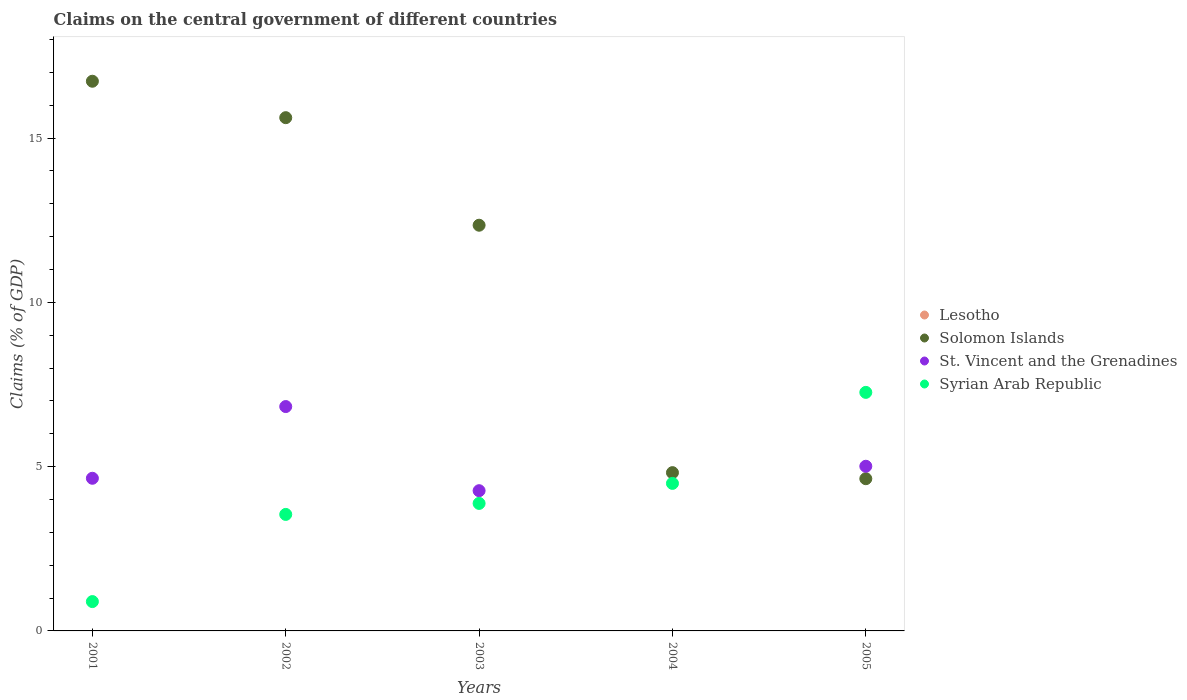Is the number of dotlines equal to the number of legend labels?
Your response must be concise. No. What is the percentage of GDP claimed on the central government in Syrian Arab Republic in 2005?
Your answer should be very brief. 7.26. Across all years, what is the maximum percentage of GDP claimed on the central government in St. Vincent and the Grenadines?
Offer a very short reply. 6.83. Across all years, what is the minimum percentage of GDP claimed on the central government in Syrian Arab Republic?
Keep it short and to the point. 0.89. What is the difference between the percentage of GDP claimed on the central government in St. Vincent and the Grenadines in 2003 and that in 2005?
Provide a short and direct response. -0.74. What is the difference between the percentage of GDP claimed on the central government in St. Vincent and the Grenadines in 2004 and the percentage of GDP claimed on the central government in Syrian Arab Republic in 2002?
Your response must be concise. -3.55. What is the average percentage of GDP claimed on the central government in Solomon Islands per year?
Your response must be concise. 10.83. In the year 2003, what is the difference between the percentage of GDP claimed on the central government in Syrian Arab Republic and percentage of GDP claimed on the central government in Solomon Islands?
Your answer should be very brief. -8.47. What is the ratio of the percentage of GDP claimed on the central government in Solomon Islands in 2004 to that in 2005?
Ensure brevity in your answer.  1.04. Is the difference between the percentage of GDP claimed on the central government in Syrian Arab Republic in 2003 and 2005 greater than the difference between the percentage of GDP claimed on the central government in Solomon Islands in 2003 and 2005?
Your answer should be very brief. No. What is the difference between the highest and the second highest percentage of GDP claimed on the central government in Solomon Islands?
Ensure brevity in your answer.  1.11. What is the difference between the highest and the lowest percentage of GDP claimed on the central government in Syrian Arab Republic?
Your answer should be very brief. 6.37. Is it the case that in every year, the sum of the percentage of GDP claimed on the central government in Solomon Islands and percentage of GDP claimed on the central government in Lesotho  is greater than the sum of percentage of GDP claimed on the central government in Syrian Arab Republic and percentage of GDP claimed on the central government in St. Vincent and the Grenadines?
Provide a succinct answer. No. Does the percentage of GDP claimed on the central government in St. Vincent and the Grenadines monotonically increase over the years?
Provide a succinct answer. No. Is the percentage of GDP claimed on the central government in Lesotho strictly greater than the percentage of GDP claimed on the central government in St. Vincent and the Grenadines over the years?
Your answer should be compact. No. How many dotlines are there?
Your answer should be compact. 3. How many years are there in the graph?
Provide a succinct answer. 5. Are the values on the major ticks of Y-axis written in scientific E-notation?
Provide a short and direct response. No. Does the graph contain any zero values?
Provide a short and direct response. Yes. Does the graph contain grids?
Your response must be concise. No. Where does the legend appear in the graph?
Offer a terse response. Center right. How many legend labels are there?
Provide a succinct answer. 4. What is the title of the graph?
Your response must be concise. Claims on the central government of different countries. Does "Iraq" appear as one of the legend labels in the graph?
Your answer should be compact. No. What is the label or title of the Y-axis?
Give a very brief answer. Claims (% of GDP). What is the Claims (% of GDP) of Lesotho in 2001?
Give a very brief answer. 0. What is the Claims (% of GDP) in Solomon Islands in 2001?
Your answer should be compact. 16.73. What is the Claims (% of GDP) of St. Vincent and the Grenadines in 2001?
Ensure brevity in your answer.  4.65. What is the Claims (% of GDP) of Syrian Arab Republic in 2001?
Ensure brevity in your answer.  0.89. What is the Claims (% of GDP) in Solomon Islands in 2002?
Give a very brief answer. 15.62. What is the Claims (% of GDP) of St. Vincent and the Grenadines in 2002?
Keep it short and to the point. 6.83. What is the Claims (% of GDP) of Syrian Arab Republic in 2002?
Offer a terse response. 3.55. What is the Claims (% of GDP) in Lesotho in 2003?
Make the answer very short. 0. What is the Claims (% of GDP) of Solomon Islands in 2003?
Offer a terse response. 12.35. What is the Claims (% of GDP) in St. Vincent and the Grenadines in 2003?
Offer a very short reply. 4.27. What is the Claims (% of GDP) of Syrian Arab Republic in 2003?
Offer a terse response. 3.88. What is the Claims (% of GDP) of Lesotho in 2004?
Your answer should be very brief. 0. What is the Claims (% of GDP) of Solomon Islands in 2004?
Offer a very short reply. 4.82. What is the Claims (% of GDP) of Syrian Arab Republic in 2004?
Offer a very short reply. 4.49. What is the Claims (% of GDP) of Lesotho in 2005?
Keep it short and to the point. 0. What is the Claims (% of GDP) in Solomon Islands in 2005?
Make the answer very short. 4.63. What is the Claims (% of GDP) of St. Vincent and the Grenadines in 2005?
Your answer should be very brief. 5.01. What is the Claims (% of GDP) in Syrian Arab Republic in 2005?
Give a very brief answer. 7.26. Across all years, what is the maximum Claims (% of GDP) in Solomon Islands?
Your answer should be very brief. 16.73. Across all years, what is the maximum Claims (% of GDP) of St. Vincent and the Grenadines?
Offer a terse response. 6.83. Across all years, what is the maximum Claims (% of GDP) of Syrian Arab Republic?
Provide a succinct answer. 7.26. Across all years, what is the minimum Claims (% of GDP) of Solomon Islands?
Provide a succinct answer. 4.63. Across all years, what is the minimum Claims (% of GDP) in St. Vincent and the Grenadines?
Make the answer very short. 0. Across all years, what is the minimum Claims (% of GDP) of Syrian Arab Republic?
Provide a short and direct response. 0.89. What is the total Claims (% of GDP) of Lesotho in the graph?
Ensure brevity in your answer.  0. What is the total Claims (% of GDP) of Solomon Islands in the graph?
Your response must be concise. 54.15. What is the total Claims (% of GDP) in St. Vincent and the Grenadines in the graph?
Your response must be concise. 20.76. What is the total Claims (% of GDP) of Syrian Arab Republic in the graph?
Provide a short and direct response. 20.07. What is the difference between the Claims (% of GDP) of Solomon Islands in 2001 and that in 2002?
Provide a short and direct response. 1.11. What is the difference between the Claims (% of GDP) of St. Vincent and the Grenadines in 2001 and that in 2002?
Offer a very short reply. -2.18. What is the difference between the Claims (% of GDP) in Syrian Arab Republic in 2001 and that in 2002?
Provide a short and direct response. -2.65. What is the difference between the Claims (% of GDP) in Solomon Islands in 2001 and that in 2003?
Your answer should be compact. 4.38. What is the difference between the Claims (% of GDP) in St. Vincent and the Grenadines in 2001 and that in 2003?
Ensure brevity in your answer.  0.38. What is the difference between the Claims (% of GDP) of Syrian Arab Republic in 2001 and that in 2003?
Ensure brevity in your answer.  -2.99. What is the difference between the Claims (% of GDP) of Solomon Islands in 2001 and that in 2004?
Provide a succinct answer. 11.91. What is the difference between the Claims (% of GDP) of Syrian Arab Republic in 2001 and that in 2004?
Ensure brevity in your answer.  -3.6. What is the difference between the Claims (% of GDP) in Solomon Islands in 2001 and that in 2005?
Make the answer very short. 12.1. What is the difference between the Claims (% of GDP) in St. Vincent and the Grenadines in 2001 and that in 2005?
Make the answer very short. -0.37. What is the difference between the Claims (% of GDP) in Syrian Arab Republic in 2001 and that in 2005?
Offer a terse response. -6.37. What is the difference between the Claims (% of GDP) of Solomon Islands in 2002 and that in 2003?
Your answer should be compact. 3.27. What is the difference between the Claims (% of GDP) in St. Vincent and the Grenadines in 2002 and that in 2003?
Give a very brief answer. 2.56. What is the difference between the Claims (% of GDP) in Syrian Arab Republic in 2002 and that in 2003?
Your answer should be very brief. -0.33. What is the difference between the Claims (% of GDP) of Solomon Islands in 2002 and that in 2004?
Ensure brevity in your answer.  10.8. What is the difference between the Claims (% of GDP) of Syrian Arab Republic in 2002 and that in 2004?
Keep it short and to the point. -0.94. What is the difference between the Claims (% of GDP) of Solomon Islands in 2002 and that in 2005?
Your answer should be very brief. 10.99. What is the difference between the Claims (% of GDP) in St. Vincent and the Grenadines in 2002 and that in 2005?
Your response must be concise. 1.82. What is the difference between the Claims (% of GDP) of Syrian Arab Republic in 2002 and that in 2005?
Offer a terse response. -3.71. What is the difference between the Claims (% of GDP) in Solomon Islands in 2003 and that in 2004?
Keep it short and to the point. 7.53. What is the difference between the Claims (% of GDP) of Syrian Arab Republic in 2003 and that in 2004?
Provide a short and direct response. -0.61. What is the difference between the Claims (% of GDP) in Solomon Islands in 2003 and that in 2005?
Ensure brevity in your answer.  7.72. What is the difference between the Claims (% of GDP) in St. Vincent and the Grenadines in 2003 and that in 2005?
Provide a succinct answer. -0.74. What is the difference between the Claims (% of GDP) in Syrian Arab Republic in 2003 and that in 2005?
Your response must be concise. -3.38. What is the difference between the Claims (% of GDP) of Solomon Islands in 2004 and that in 2005?
Your response must be concise. 0.18. What is the difference between the Claims (% of GDP) in Syrian Arab Republic in 2004 and that in 2005?
Your response must be concise. -2.77. What is the difference between the Claims (% of GDP) in Solomon Islands in 2001 and the Claims (% of GDP) in St. Vincent and the Grenadines in 2002?
Your answer should be compact. 9.9. What is the difference between the Claims (% of GDP) of Solomon Islands in 2001 and the Claims (% of GDP) of Syrian Arab Republic in 2002?
Your response must be concise. 13.18. What is the difference between the Claims (% of GDP) of Solomon Islands in 2001 and the Claims (% of GDP) of St. Vincent and the Grenadines in 2003?
Provide a short and direct response. 12.46. What is the difference between the Claims (% of GDP) of Solomon Islands in 2001 and the Claims (% of GDP) of Syrian Arab Republic in 2003?
Keep it short and to the point. 12.85. What is the difference between the Claims (% of GDP) in St. Vincent and the Grenadines in 2001 and the Claims (% of GDP) in Syrian Arab Republic in 2003?
Your answer should be very brief. 0.77. What is the difference between the Claims (% of GDP) of Solomon Islands in 2001 and the Claims (% of GDP) of Syrian Arab Republic in 2004?
Your answer should be very brief. 12.24. What is the difference between the Claims (% of GDP) of St. Vincent and the Grenadines in 2001 and the Claims (% of GDP) of Syrian Arab Republic in 2004?
Your answer should be very brief. 0.16. What is the difference between the Claims (% of GDP) in Solomon Islands in 2001 and the Claims (% of GDP) in St. Vincent and the Grenadines in 2005?
Offer a terse response. 11.72. What is the difference between the Claims (% of GDP) in Solomon Islands in 2001 and the Claims (% of GDP) in Syrian Arab Republic in 2005?
Offer a very short reply. 9.47. What is the difference between the Claims (% of GDP) of St. Vincent and the Grenadines in 2001 and the Claims (% of GDP) of Syrian Arab Republic in 2005?
Provide a short and direct response. -2.61. What is the difference between the Claims (% of GDP) of Solomon Islands in 2002 and the Claims (% of GDP) of St. Vincent and the Grenadines in 2003?
Offer a very short reply. 11.35. What is the difference between the Claims (% of GDP) in Solomon Islands in 2002 and the Claims (% of GDP) in Syrian Arab Republic in 2003?
Offer a terse response. 11.74. What is the difference between the Claims (% of GDP) in St. Vincent and the Grenadines in 2002 and the Claims (% of GDP) in Syrian Arab Republic in 2003?
Keep it short and to the point. 2.95. What is the difference between the Claims (% of GDP) in Solomon Islands in 2002 and the Claims (% of GDP) in Syrian Arab Republic in 2004?
Your response must be concise. 11.13. What is the difference between the Claims (% of GDP) in St. Vincent and the Grenadines in 2002 and the Claims (% of GDP) in Syrian Arab Republic in 2004?
Keep it short and to the point. 2.34. What is the difference between the Claims (% of GDP) of Solomon Islands in 2002 and the Claims (% of GDP) of St. Vincent and the Grenadines in 2005?
Provide a succinct answer. 10.61. What is the difference between the Claims (% of GDP) in Solomon Islands in 2002 and the Claims (% of GDP) in Syrian Arab Republic in 2005?
Ensure brevity in your answer.  8.36. What is the difference between the Claims (% of GDP) of St. Vincent and the Grenadines in 2002 and the Claims (% of GDP) of Syrian Arab Republic in 2005?
Provide a short and direct response. -0.43. What is the difference between the Claims (% of GDP) of Solomon Islands in 2003 and the Claims (% of GDP) of Syrian Arab Republic in 2004?
Provide a short and direct response. 7.86. What is the difference between the Claims (% of GDP) of St. Vincent and the Grenadines in 2003 and the Claims (% of GDP) of Syrian Arab Republic in 2004?
Provide a short and direct response. -0.22. What is the difference between the Claims (% of GDP) of Solomon Islands in 2003 and the Claims (% of GDP) of St. Vincent and the Grenadines in 2005?
Offer a very short reply. 7.34. What is the difference between the Claims (% of GDP) in Solomon Islands in 2003 and the Claims (% of GDP) in Syrian Arab Republic in 2005?
Give a very brief answer. 5.09. What is the difference between the Claims (% of GDP) in St. Vincent and the Grenadines in 2003 and the Claims (% of GDP) in Syrian Arab Republic in 2005?
Your answer should be very brief. -2.99. What is the difference between the Claims (% of GDP) in Solomon Islands in 2004 and the Claims (% of GDP) in St. Vincent and the Grenadines in 2005?
Make the answer very short. -0.19. What is the difference between the Claims (% of GDP) in Solomon Islands in 2004 and the Claims (% of GDP) in Syrian Arab Republic in 2005?
Your answer should be very brief. -2.44. What is the average Claims (% of GDP) in Lesotho per year?
Your response must be concise. 0. What is the average Claims (% of GDP) of Solomon Islands per year?
Ensure brevity in your answer.  10.83. What is the average Claims (% of GDP) in St. Vincent and the Grenadines per year?
Give a very brief answer. 4.15. What is the average Claims (% of GDP) of Syrian Arab Republic per year?
Provide a succinct answer. 4.01. In the year 2001, what is the difference between the Claims (% of GDP) in Solomon Islands and Claims (% of GDP) in St. Vincent and the Grenadines?
Your answer should be compact. 12.08. In the year 2001, what is the difference between the Claims (% of GDP) of Solomon Islands and Claims (% of GDP) of Syrian Arab Republic?
Offer a terse response. 15.84. In the year 2001, what is the difference between the Claims (% of GDP) of St. Vincent and the Grenadines and Claims (% of GDP) of Syrian Arab Republic?
Your answer should be compact. 3.75. In the year 2002, what is the difference between the Claims (% of GDP) in Solomon Islands and Claims (% of GDP) in St. Vincent and the Grenadines?
Offer a terse response. 8.79. In the year 2002, what is the difference between the Claims (% of GDP) of Solomon Islands and Claims (% of GDP) of Syrian Arab Republic?
Your response must be concise. 12.08. In the year 2002, what is the difference between the Claims (% of GDP) in St. Vincent and the Grenadines and Claims (% of GDP) in Syrian Arab Republic?
Your answer should be very brief. 3.28. In the year 2003, what is the difference between the Claims (% of GDP) in Solomon Islands and Claims (% of GDP) in St. Vincent and the Grenadines?
Make the answer very short. 8.08. In the year 2003, what is the difference between the Claims (% of GDP) in Solomon Islands and Claims (% of GDP) in Syrian Arab Republic?
Make the answer very short. 8.47. In the year 2003, what is the difference between the Claims (% of GDP) in St. Vincent and the Grenadines and Claims (% of GDP) in Syrian Arab Republic?
Your answer should be compact. 0.39. In the year 2004, what is the difference between the Claims (% of GDP) of Solomon Islands and Claims (% of GDP) of Syrian Arab Republic?
Provide a short and direct response. 0.33. In the year 2005, what is the difference between the Claims (% of GDP) of Solomon Islands and Claims (% of GDP) of St. Vincent and the Grenadines?
Ensure brevity in your answer.  -0.38. In the year 2005, what is the difference between the Claims (% of GDP) in Solomon Islands and Claims (% of GDP) in Syrian Arab Republic?
Offer a terse response. -2.63. In the year 2005, what is the difference between the Claims (% of GDP) of St. Vincent and the Grenadines and Claims (% of GDP) of Syrian Arab Republic?
Your answer should be very brief. -2.25. What is the ratio of the Claims (% of GDP) of Solomon Islands in 2001 to that in 2002?
Give a very brief answer. 1.07. What is the ratio of the Claims (% of GDP) of St. Vincent and the Grenadines in 2001 to that in 2002?
Your response must be concise. 0.68. What is the ratio of the Claims (% of GDP) in Syrian Arab Republic in 2001 to that in 2002?
Make the answer very short. 0.25. What is the ratio of the Claims (% of GDP) of Solomon Islands in 2001 to that in 2003?
Provide a short and direct response. 1.35. What is the ratio of the Claims (% of GDP) of St. Vincent and the Grenadines in 2001 to that in 2003?
Your answer should be very brief. 1.09. What is the ratio of the Claims (% of GDP) of Syrian Arab Republic in 2001 to that in 2003?
Give a very brief answer. 0.23. What is the ratio of the Claims (% of GDP) in Solomon Islands in 2001 to that in 2004?
Keep it short and to the point. 3.47. What is the ratio of the Claims (% of GDP) of Syrian Arab Republic in 2001 to that in 2004?
Give a very brief answer. 0.2. What is the ratio of the Claims (% of GDP) of Solomon Islands in 2001 to that in 2005?
Your answer should be compact. 3.61. What is the ratio of the Claims (% of GDP) of St. Vincent and the Grenadines in 2001 to that in 2005?
Provide a succinct answer. 0.93. What is the ratio of the Claims (% of GDP) in Syrian Arab Republic in 2001 to that in 2005?
Keep it short and to the point. 0.12. What is the ratio of the Claims (% of GDP) of Solomon Islands in 2002 to that in 2003?
Keep it short and to the point. 1.27. What is the ratio of the Claims (% of GDP) in St. Vincent and the Grenadines in 2002 to that in 2003?
Provide a short and direct response. 1.6. What is the ratio of the Claims (% of GDP) in Syrian Arab Republic in 2002 to that in 2003?
Your response must be concise. 0.91. What is the ratio of the Claims (% of GDP) in Solomon Islands in 2002 to that in 2004?
Keep it short and to the point. 3.24. What is the ratio of the Claims (% of GDP) in Syrian Arab Republic in 2002 to that in 2004?
Offer a very short reply. 0.79. What is the ratio of the Claims (% of GDP) of Solomon Islands in 2002 to that in 2005?
Make the answer very short. 3.37. What is the ratio of the Claims (% of GDP) of St. Vincent and the Grenadines in 2002 to that in 2005?
Offer a terse response. 1.36. What is the ratio of the Claims (% of GDP) of Syrian Arab Republic in 2002 to that in 2005?
Give a very brief answer. 0.49. What is the ratio of the Claims (% of GDP) of Solomon Islands in 2003 to that in 2004?
Your answer should be very brief. 2.56. What is the ratio of the Claims (% of GDP) in Syrian Arab Republic in 2003 to that in 2004?
Keep it short and to the point. 0.86. What is the ratio of the Claims (% of GDP) of Solomon Islands in 2003 to that in 2005?
Make the answer very short. 2.67. What is the ratio of the Claims (% of GDP) in St. Vincent and the Grenadines in 2003 to that in 2005?
Provide a succinct answer. 0.85. What is the ratio of the Claims (% of GDP) in Syrian Arab Republic in 2003 to that in 2005?
Provide a succinct answer. 0.53. What is the ratio of the Claims (% of GDP) of Solomon Islands in 2004 to that in 2005?
Your response must be concise. 1.04. What is the ratio of the Claims (% of GDP) of Syrian Arab Republic in 2004 to that in 2005?
Provide a short and direct response. 0.62. What is the difference between the highest and the second highest Claims (% of GDP) in Solomon Islands?
Your response must be concise. 1.11. What is the difference between the highest and the second highest Claims (% of GDP) of St. Vincent and the Grenadines?
Your response must be concise. 1.82. What is the difference between the highest and the second highest Claims (% of GDP) in Syrian Arab Republic?
Offer a terse response. 2.77. What is the difference between the highest and the lowest Claims (% of GDP) of Solomon Islands?
Ensure brevity in your answer.  12.1. What is the difference between the highest and the lowest Claims (% of GDP) of St. Vincent and the Grenadines?
Offer a very short reply. 6.83. What is the difference between the highest and the lowest Claims (% of GDP) of Syrian Arab Republic?
Provide a succinct answer. 6.37. 